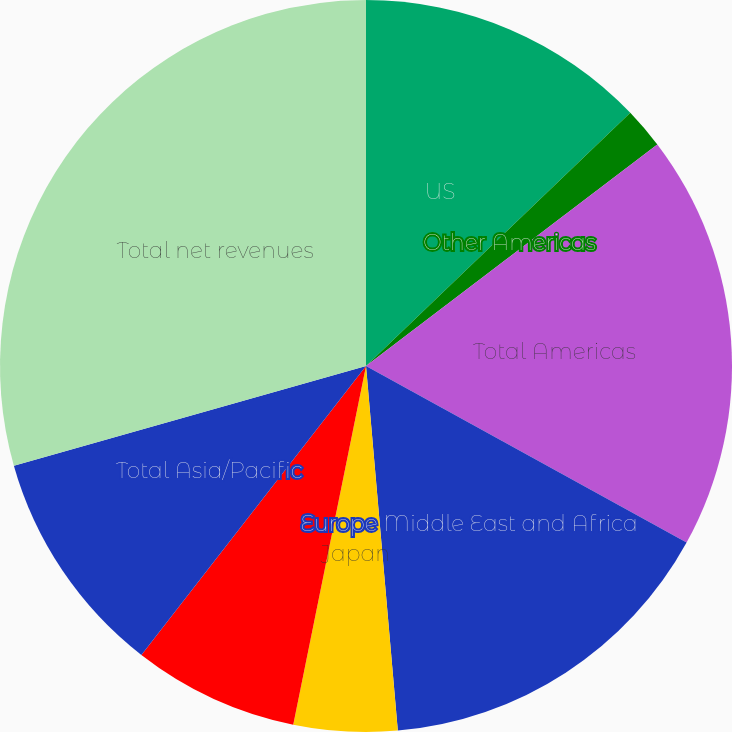Convert chart to OTSL. <chart><loc_0><loc_0><loc_500><loc_500><pie_chart><fcel>US<fcel>Other Americas<fcel>Total Americas<fcel>Europe Middle East and Africa<fcel>Japan<fcel>Other Asia/Pacific<fcel>Total Asia/Pacific<fcel>Total net revenues<nl><fcel>12.84%<fcel>1.81%<fcel>18.36%<fcel>15.6%<fcel>4.57%<fcel>7.33%<fcel>10.09%<fcel>29.39%<nl></chart> 